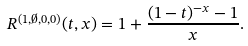Convert formula to latex. <formula><loc_0><loc_0><loc_500><loc_500>R ^ { ( 1 , \emptyset , 0 , 0 ) } ( t , x ) = 1 + \frac { ( 1 - t ) ^ { - x } - 1 } { x } .</formula> 